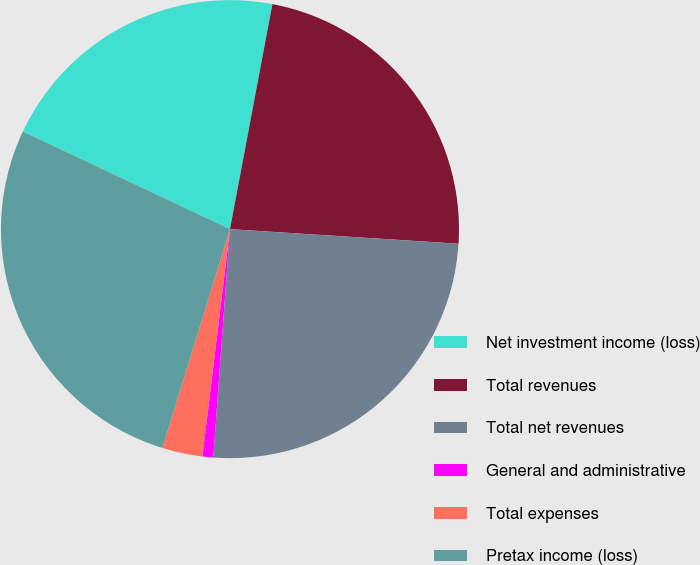Convert chart to OTSL. <chart><loc_0><loc_0><loc_500><loc_500><pie_chart><fcel>Net investment income (loss)<fcel>Total revenues<fcel>Total net revenues<fcel>General and administrative<fcel>Total expenses<fcel>Pretax income (loss)<nl><fcel>20.96%<fcel>23.05%<fcel>25.15%<fcel>0.76%<fcel>2.85%<fcel>27.24%<nl></chart> 